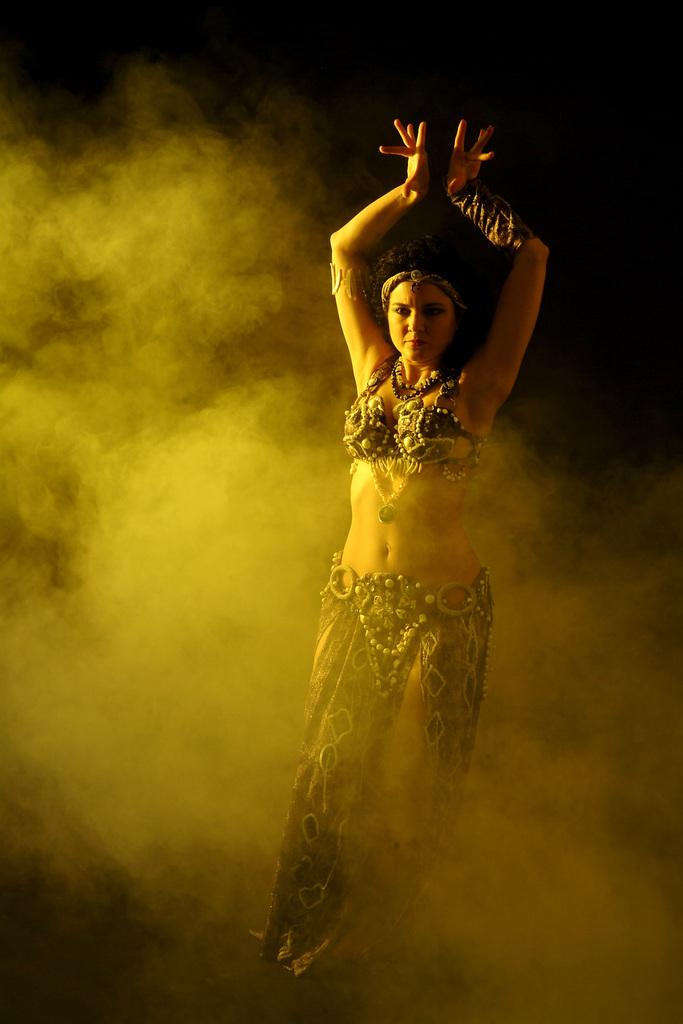Who is the main subject in the foreground of the image? There is a woman in the foreground of the image. What is the woman doing in the image? The woman is dancing. What is the atmospheric condition in the image? There is fog in the image. How would you describe the lighting in the background of the image? The background of the image is dark. How many geese are flying in the image? There are no geese present in the image. What type of spark can be seen coming from the woman's hands while she dances? There is no spark visible in the image; the woman is simply dancing. 